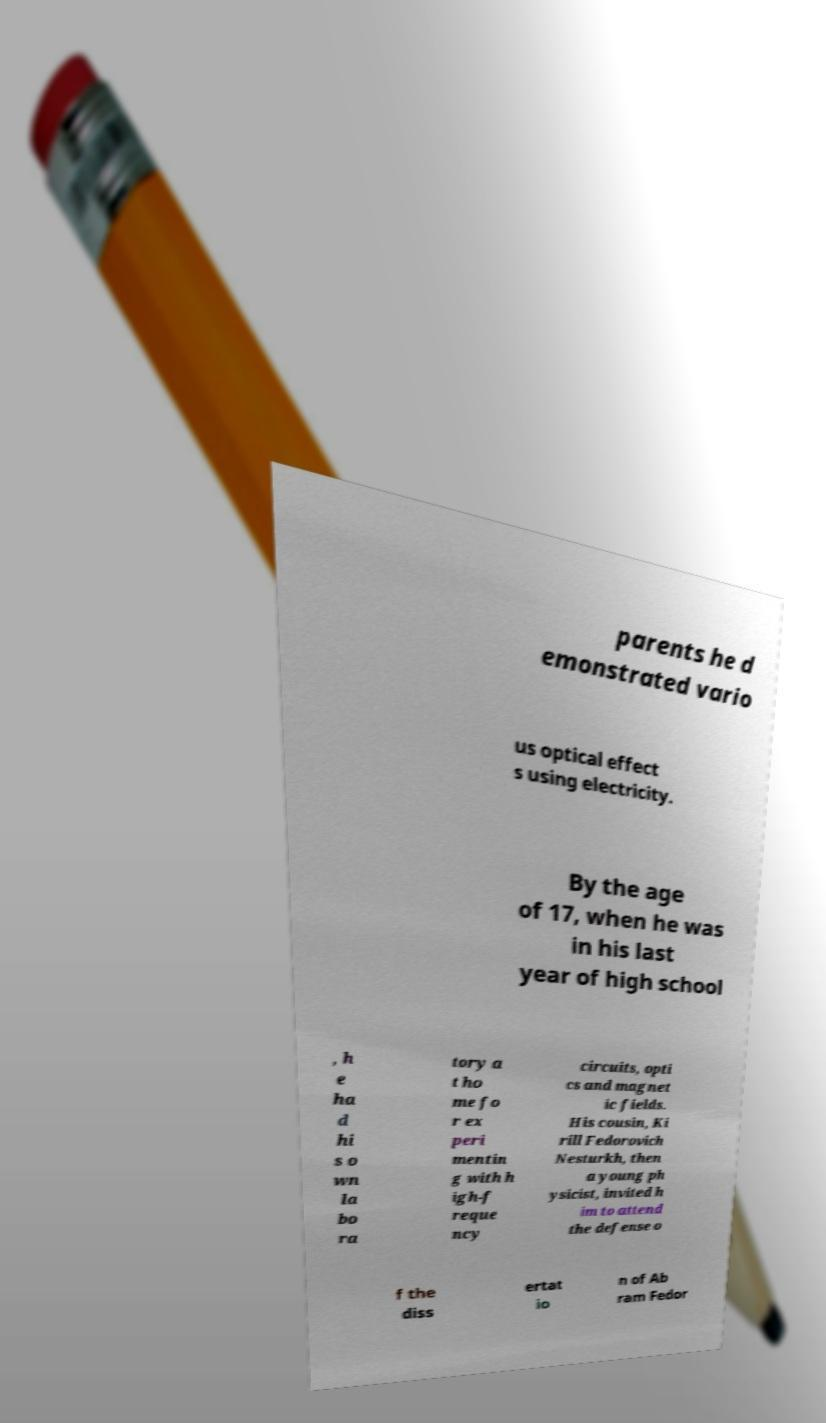What messages or text are displayed in this image? I need them in a readable, typed format. parents he d emonstrated vario us optical effect s using electricity. By the age of 17, when he was in his last year of high school , h e ha d hi s o wn la bo ra tory a t ho me fo r ex peri mentin g with h igh-f reque ncy circuits, opti cs and magnet ic fields. His cousin, Ki rill Fedorovich Nesturkh, then a young ph ysicist, invited h im to attend the defense o f the diss ertat io n of Ab ram Fedor 